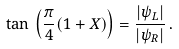<formula> <loc_0><loc_0><loc_500><loc_500>\tan \, \left ( \frac { \pi } { 4 } ( 1 + X ) \right ) = \frac { | \psi _ { L } | } { | \psi _ { R } | } \, .</formula> 